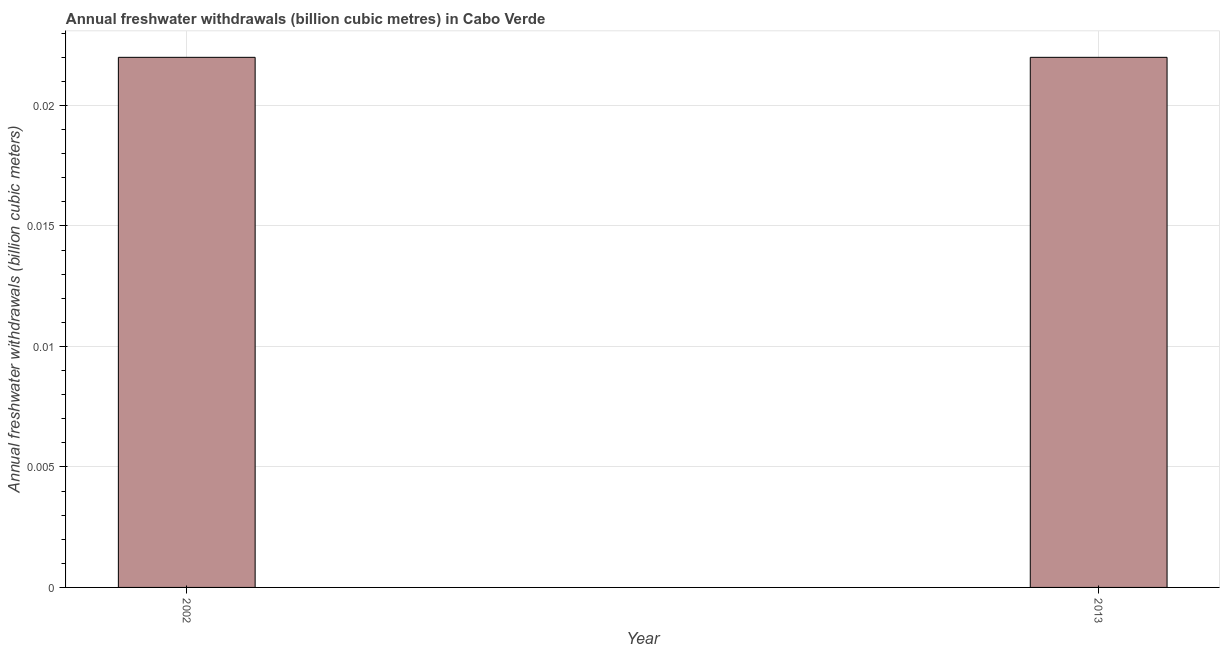Does the graph contain any zero values?
Give a very brief answer. No. Does the graph contain grids?
Offer a very short reply. Yes. What is the title of the graph?
Keep it short and to the point. Annual freshwater withdrawals (billion cubic metres) in Cabo Verde. What is the label or title of the Y-axis?
Offer a very short reply. Annual freshwater withdrawals (billion cubic meters). What is the annual freshwater withdrawals in 2002?
Provide a short and direct response. 0.02. Across all years, what is the maximum annual freshwater withdrawals?
Your response must be concise. 0.02. Across all years, what is the minimum annual freshwater withdrawals?
Your answer should be very brief. 0.02. In which year was the annual freshwater withdrawals maximum?
Ensure brevity in your answer.  2002. What is the sum of the annual freshwater withdrawals?
Offer a very short reply. 0.04. What is the average annual freshwater withdrawals per year?
Give a very brief answer. 0.02. What is the median annual freshwater withdrawals?
Provide a succinct answer. 0.02. What is the ratio of the annual freshwater withdrawals in 2002 to that in 2013?
Provide a short and direct response. 1. How many years are there in the graph?
Make the answer very short. 2. What is the difference between two consecutive major ticks on the Y-axis?
Offer a very short reply. 0.01. What is the Annual freshwater withdrawals (billion cubic meters) of 2002?
Your answer should be compact. 0.02. What is the Annual freshwater withdrawals (billion cubic meters) of 2013?
Give a very brief answer. 0.02. What is the ratio of the Annual freshwater withdrawals (billion cubic meters) in 2002 to that in 2013?
Your answer should be very brief. 1. 